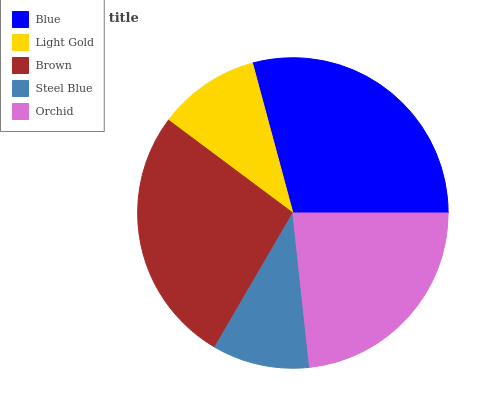Is Steel Blue the minimum?
Answer yes or no. Yes. Is Blue the maximum?
Answer yes or no. Yes. Is Light Gold the minimum?
Answer yes or no. No. Is Light Gold the maximum?
Answer yes or no. No. Is Blue greater than Light Gold?
Answer yes or no. Yes. Is Light Gold less than Blue?
Answer yes or no. Yes. Is Light Gold greater than Blue?
Answer yes or no. No. Is Blue less than Light Gold?
Answer yes or no. No. Is Orchid the high median?
Answer yes or no. Yes. Is Orchid the low median?
Answer yes or no. Yes. Is Light Gold the high median?
Answer yes or no. No. Is Steel Blue the low median?
Answer yes or no. No. 